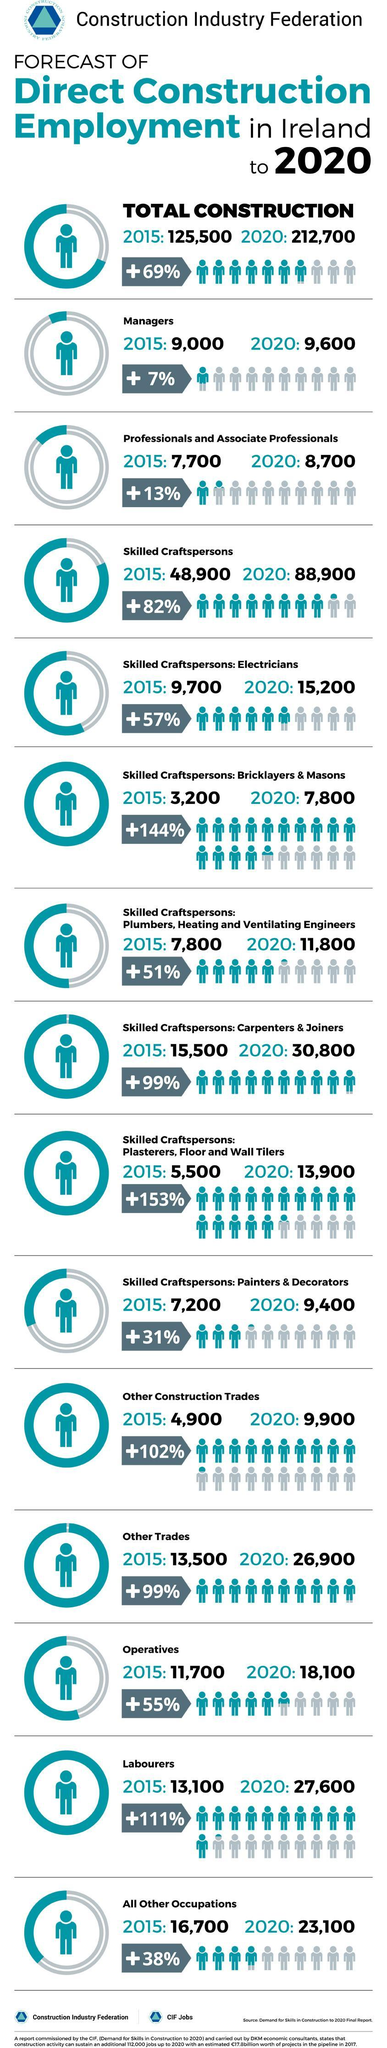What is the estimated percentage increase of labourers in Ireland by 2020?
Answer the question with a short phrase. 111% What is the number of painters & decorators employed in Ireland in 2015? 7,200 What is the number of carpenters & joiners employed in Ireland in 2015? 15,500 What is the estimated number of Electricians to be employed in Ireland by 2020? 15,200 What is the estimated percentage increase of skilled craftspersons in Ireland by 2020? 82% 